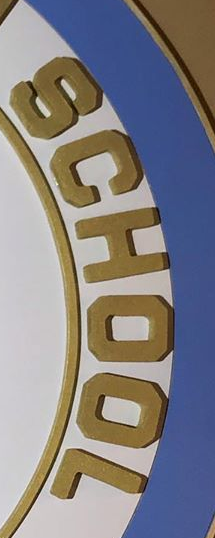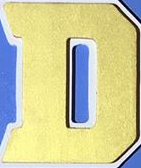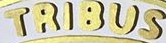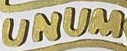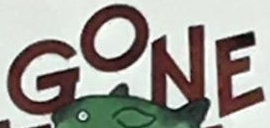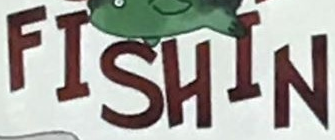Read the text from these images in sequence, separated by a semicolon. SCHOOL; D; TRIBUS; UNUM; GONE; FISHIN 